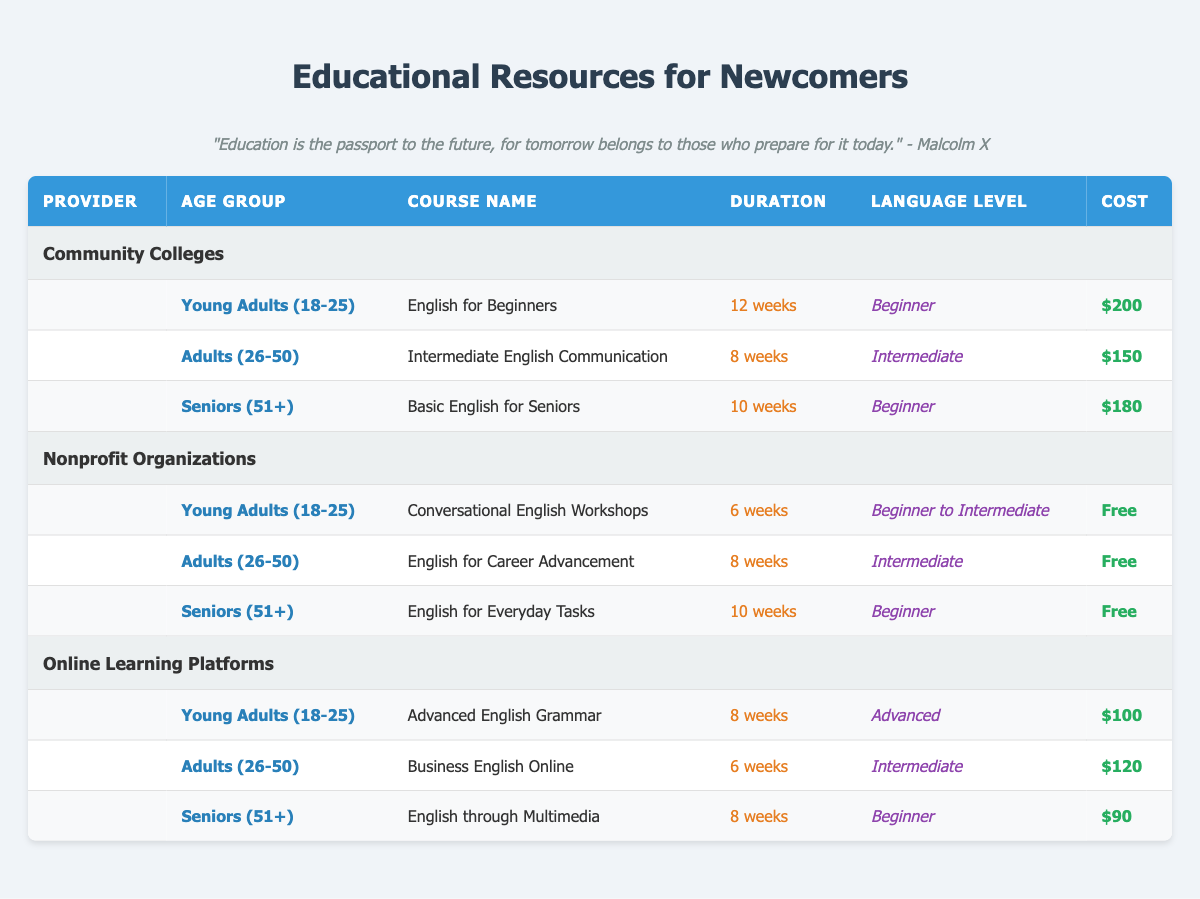What is the duration of the "English for Beginners" course? The course "English for Beginners" is listed under the "Community Colleges" provider for the age group "Young Adults (18-25). The duration is specified as "12 weeks."
Answer: 12 weeks What is the cost of the "Conversational English Workshops"? The course "Conversational English Workshops" is offered for free by Nonprofit Organizations to the age group "Young Adults (18-25)." The cost is stated clearly as "Free."
Answer: Free Which provider offers "English for Everyday Tasks" and what is its duration? "English for Everyday Tasks" is offered by Nonprofit Organizations to the age group of "Seniors (51+)." The duration for this course is listed as "10 weeks."
Answer: Nonprofit Organizations, 10 weeks Is there a course for Seniors that costs less than $100? The available courses for Seniors are "Basic English for Seniors" from Community Colleges ($180), "English for Everyday Tasks" from Nonprofit Organizations (Free), and "English through Multimedia" from Online Learning Platforms ($90). Out of these, "English for Everyday Tasks" is free, which is less than $100. Therefore, the statement is true.
Answer: Yes What is the average cost of the courses for Adults (26-50)? The courses for Adults (26-50) are "Intermediate English Communication" ($150) from Community Colleges, "English for Career Advancement" (Free) from Nonprofit Organizations, and "Business English Online" ($120) from Online Learning Platforms. To find the average cost, first, consider the cost of the free course as $0. The total cost is $150 + $0 + $120 = $270; dividing by 3 gives an average of 270 / 3 = $90.
Answer: $90 Which course has the longest duration among the listed titles? The longest duration course is "English for Beginners," which lasts for "12 weeks." None of the other courses exceed this duration, as the maximum duration from other courses is 10 weeks ("Basic English for Seniors" and "English for Everyday Tasks").
Answer: English for Beginners How many courses are available for Young Adults (18-25)? The courses available for the Young Adults (18-25) age group are: "English for Beginners" from Community Colleges, "Conversational English Workshops" from Nonprofit Organizations, and "Advanced English Grammar" from Online Learning Platforms. In total, there are 3 courses offered for this age group.
Answer: 3 What is the language level of "Business English Online"? "Business English Online" is offered to Adults (26-50) through Online Learning Platforms, and it is classified at an "Intermediate" language level. This information can be directly referenced from the respective row in the table.
Answer: Intermediate 